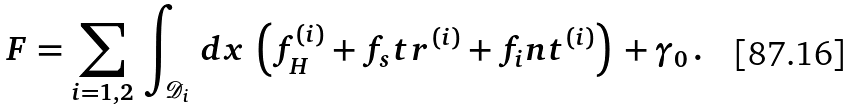Convert formula to latex. <formula><loc_0><loc_0><loc_500><loc_500>F = \sum _ { i = 1 , 2 } \, \int _ { \mathcal { D } _ { i } } \, d x \, \left ( f _ { H } ^ { ( i ) } + f _ { s } t r ^ { ( i ) } + f _ { i } n t ^ { ( i ) } \right ) \, + \gamma _ { 0 } \, .</formula> 